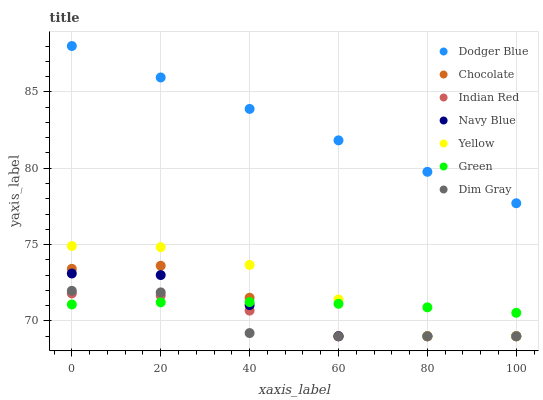Does Dim Gray have the minimum area under the curve?
Answer yes or no. Yes. Does Dodger Blue have the maximum area under the curve?
Answer yes or no. Yes. Does Navy Blue have the minimum area under the curve?
Answer yes or no. No. Does Navy Blue have the maximum area under the curve?
Answer yes or no. No. Is Dodger Blue the smoothest?
Answer yes or no. Yes. Is Chocolate the roughest?
Answer yes or no. Yes. Is Navy Blue the smoothest?
Answer yes or no. No. Is Navy Blue the roughest?
Answer yes or no. No. Does Dim Gray have the lowest value?
Answer yes or no. Yes. Does Green have the lowest value?
Answer yes or no. No. Does Dodger Blue have the highest value?
Answer yes or no. Yes. Does Navy Blue have the highest value?
Answer yes or no. No. Is Indian Red less than Dodger Blue?
Answer yes or no. Yes. Is Dodger Blue greater than Dim Gray?
Answer yes or no. Yes. Does Navy Blue intersect Chocolate?
Answer yes or no. Yes. Is Navy Blue less than Chocolate?
Answer yes or no. No. Is Navy Blue greater than Chocolate?
Answer yes or no. No. Does Indian Red intersect Dodger Blue?
Answer yes or no. No. 